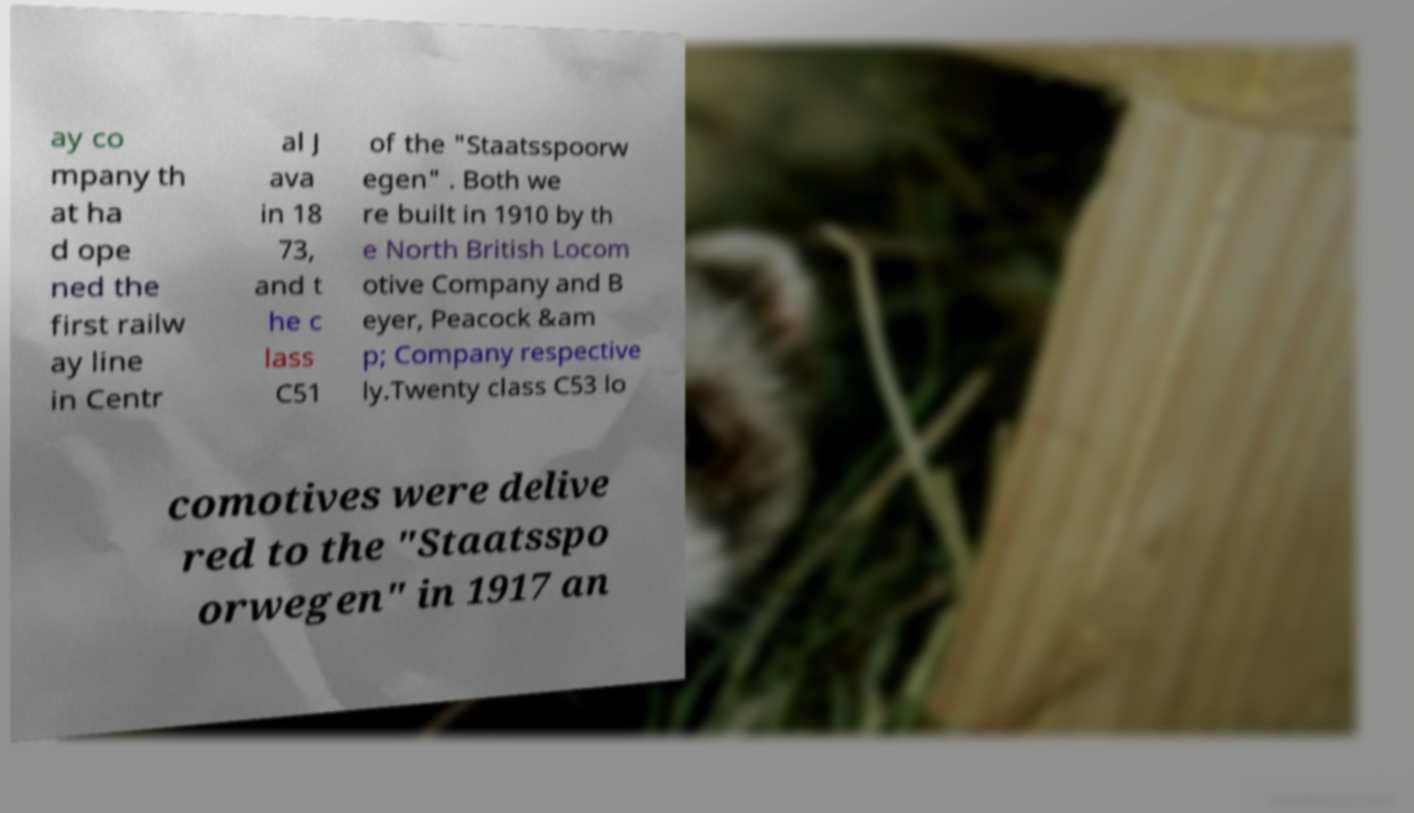Could you extract and type out the text from this image? ay co mpany th at ha d ope ned the first railw ay line in Centr al J ava in 18 73, and t he c lass C51 of the "Staatsspoorw egen" . Both we re built in 1910 by th e North British Locom otive Company and B eyer, Peacock &am p; Company respective ly.Twenty class C53 lo comotives were delive red to the "Staatsspo orwegen" in 1917 an 